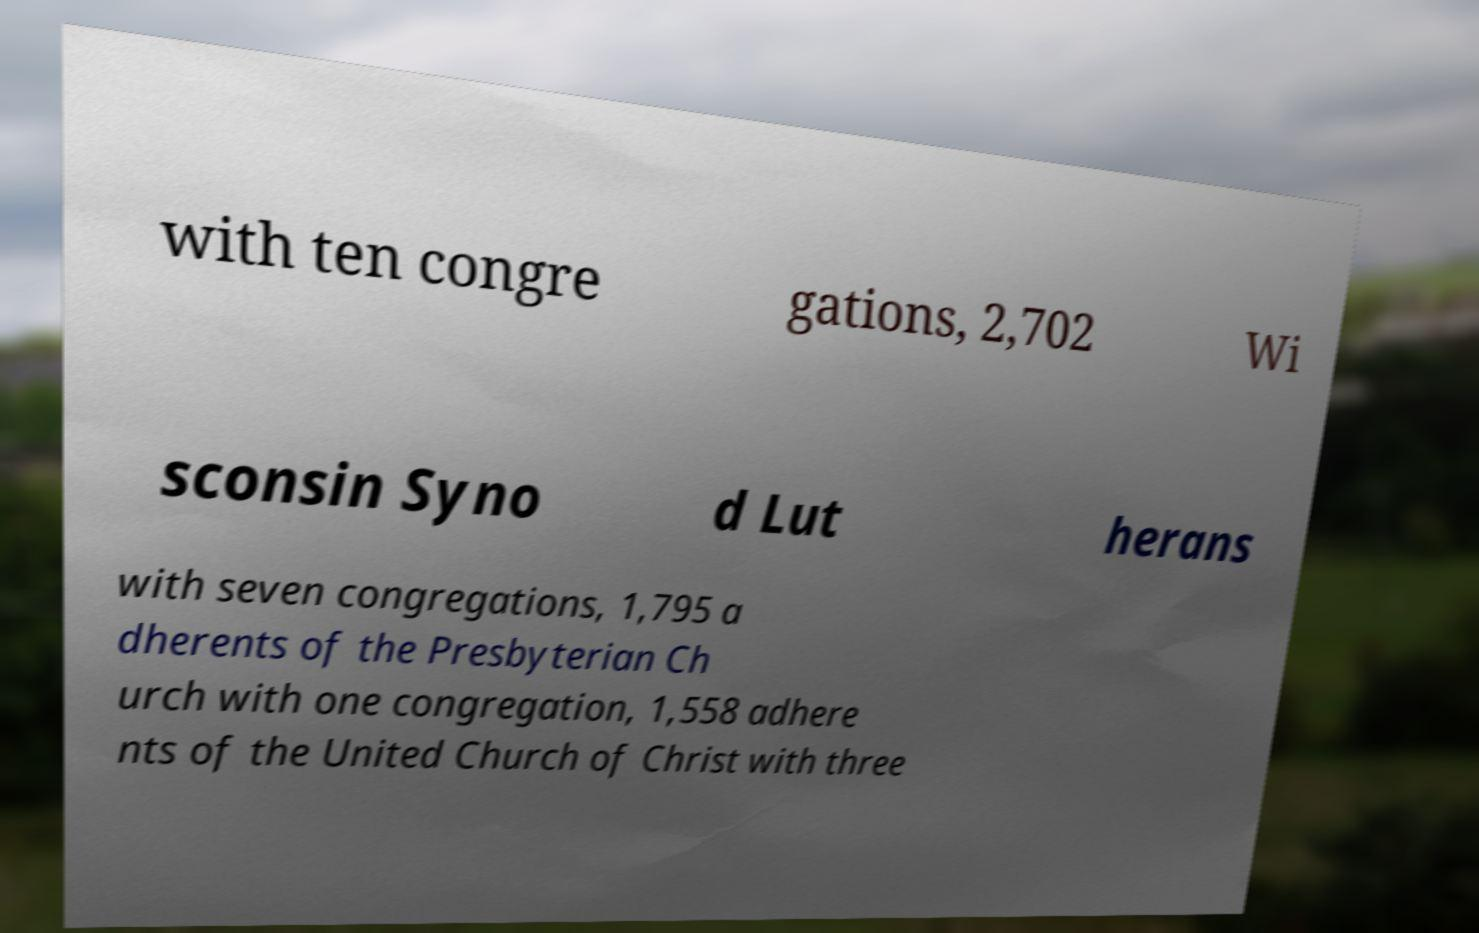I need the written content from this picture converted into text. Can you do that? with ten congre gations, 2,702 Wi sconsin Syno d Lut herans with seven congregations, 1,795 a dherents of the Presbyterian Ch urch with one congregation, 1,558 adhere nts of the United Church of Christ with three 